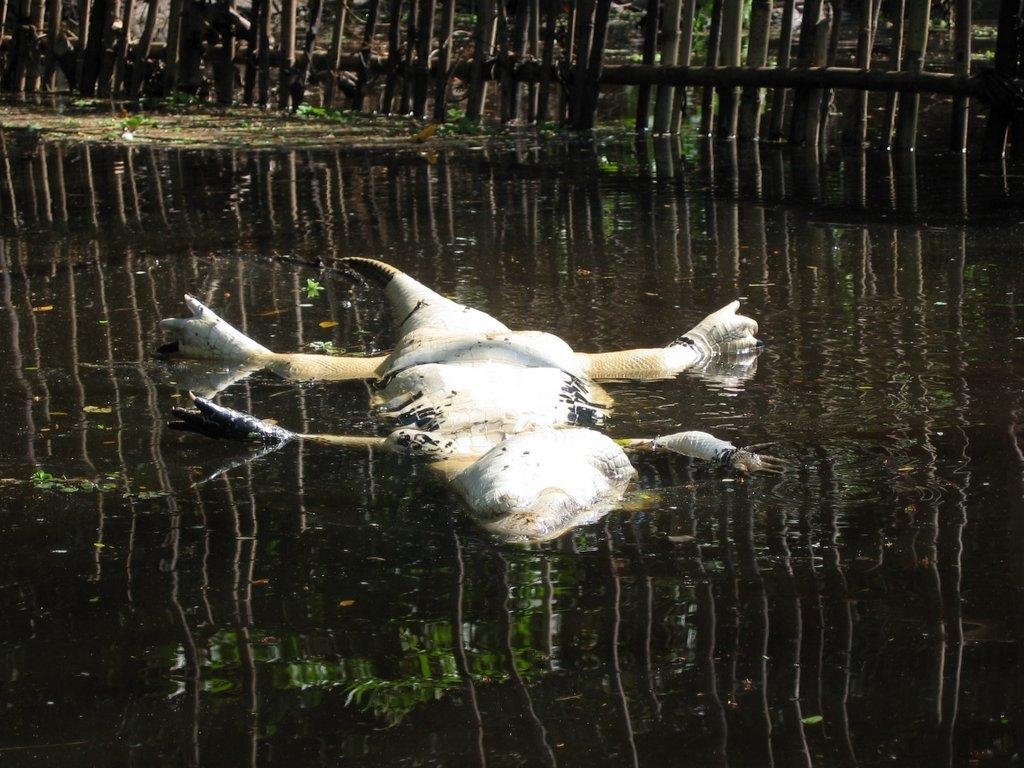What type of animal is in the image? There is a bird in the image. What is the bird doing in the image? The bird is floating on the water. What can be seen in the water besides the bird? There are reflections visible in the water. What are the reflections of? The reflections are of staves. What type of grain can be seen in the image? There is no grain present in the image; it features a bird floating on the water with reflections of staves. 